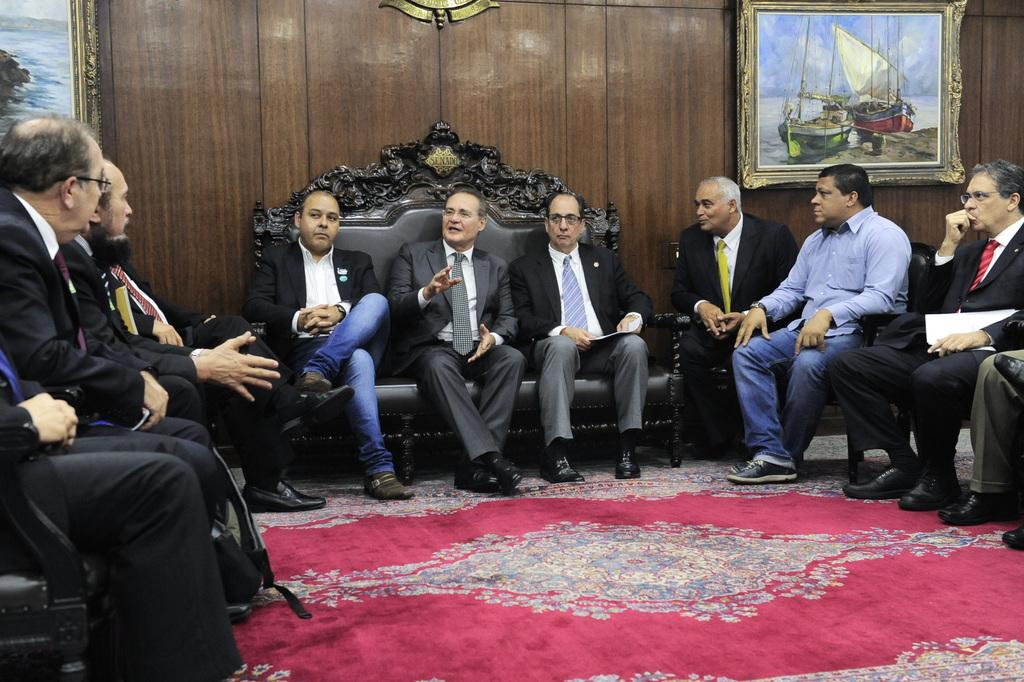What are the men in the image wearing? The men in the image are wearing suits. What are the men doing in the image? The men are sitting on a sofa in the image. Where are the men located in the image? The men are inside a room in the image. What can be seen on the walls of the room? There are paintings on the wall in the room. What is on the floor of the room? There is a red carpet on the floor in the room. What type of approval are the men in the image seeking from the servant? There is no servant present in the image, and therefore no approval-seeking can be observed. 